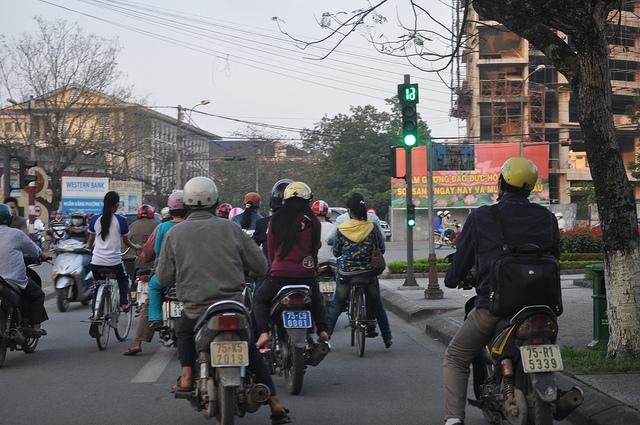What color are the numbers on the top of the pole with the traffic lights? Please explain your reasoning. green. They are the same color as the light signifying it's safe to go. 